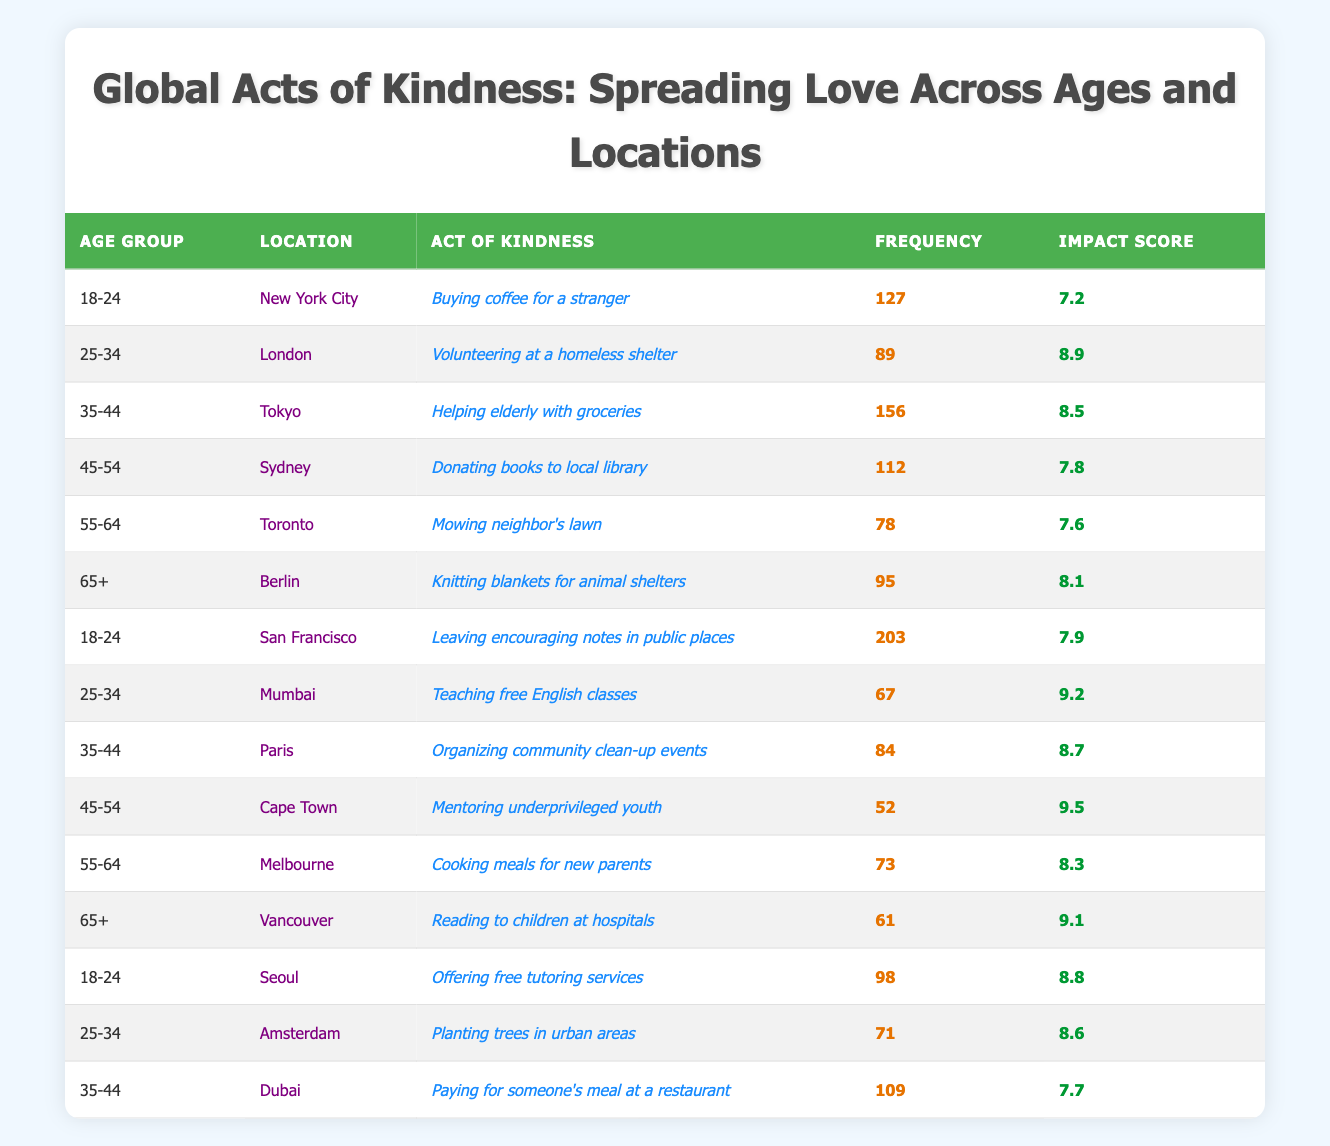What is the act of kindness with the highest frequency among the age group 18-24? By examining the entries for the age group 18-24 in the table, I see two acts of kindness: "Buying coffee for a stranger" with a frequency of 127 and "Leaving encouraging notes in public places" with a frequency of 203. The act with the highest frequency is "Leaving encouraging notes in public places" with a frequency of 203.
Answer: Leaving encouraging notes in public places Which location has the highest impact score for acts of kindness among the age group 25-34? I reviewed all entries in the age group 25-34. The acts of kindness listed are "Volunteering at a homeless shelter" in London with an impact score of 8.9, "Teaching free English classes" in Mumbai with an impact score of 9.2, and "Planting trees in urban areas" in Amsterdam with an impact score of 8.6. The highest impact score in this age group is 9.2 from Mumbai.
Answer: Mumbai How many acts of kindness were recorded for the age group 35-44? The table lists three acts of kindness under the age group 35-44: "Helping elderly with groceries", "Organizing community clean-up events", and "Paying for someone's meal at a restaurant". Therefore, the total number of acts of kindness recorded for this age group is three.
Answer: 3 Is there any act of kindness in the 65+ age group that has an impact score greater than 9? In the 65+ age group, the acts of kindness recorded are "Knitting blankets for animal shelters" with an impact score of 8.1 and "Reading to children at hospitals" with an impact score of 9.1. Since 9.1 is greater than 9, the answer is yes.
Answer: Yes What is the average frequency of acts of kindness across all age groups? To find the average frequency, I sum the frequency values from each entry in the table: (127 + 89 + 156 + 112 + 78 + 95 + 203 + 67 + 84 + 52 + 73 + 61 + 98 + 71 + 109) = 1,473. There are 15 acts of kindness recorded, so the average is 1,473 divided by 15, which equals 98.2.
Answer: 98.2 Which act of kindness in the age group 55-64 has the highest frequency? For the age group 55-64, the acts of kindness listed are "Mowing neighbor's lawn" with a frequency of 78 and "Cooking meals for new parents" with a frequency of 73. The act with the highest frequency is "Mowing neighbor's lawn" with a frequency of 78.
Answer: Mowing neighbor's lawn In which location do people aged 45-54 perform acts of kindness with the highest frequency? For the age group 45-54, the acts of kindness are "Donating books to local library" in Sydney with a frequency of 112 and "Mentoring underprivileged youth" in Cape Town with a frequency of 52. Sydney has the highest frequency of 112.
Answer: Sydney How many acts of kindness were performed in Toronto? In the table, I can find only one act of kindness listed in Toronto: "Mowing neighbor's lawn" with a frequency of 78. Therefore, only one act of kindness is recorded in Toronto.
Answer: 1 